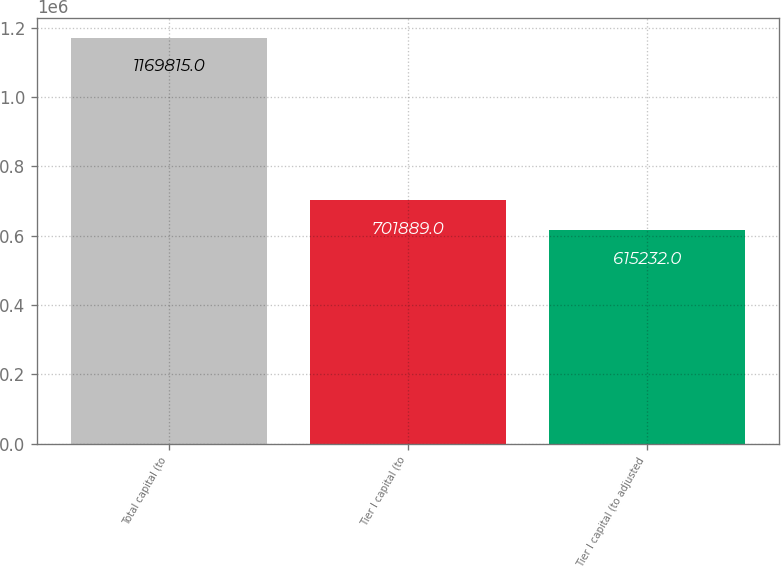<chart> <loc_0><loc_0><loc_500><loc_500><bar_chart><fcel>Total capital (to<fcel>Tier I capital (to<fcel>Tier I capital (to adjusted<nl><fcel>1.16982e+06<fcel>701889<fcel>615232<nl></chart> 